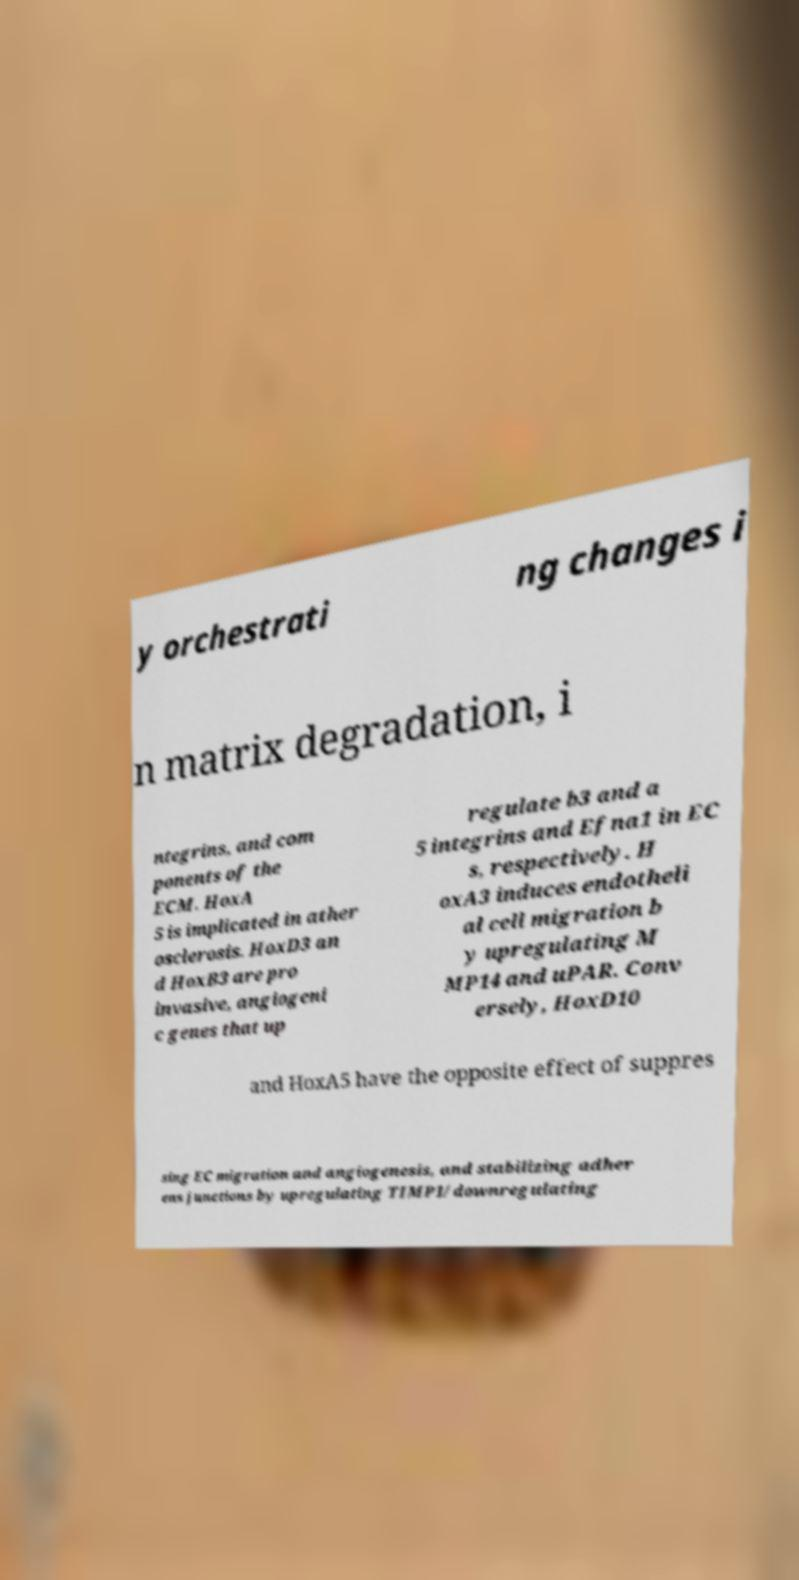What messages or text are displayed in this image? I need them in a readable, typed format. y orchestrati ng changes i n matrix degradation, i ntegrins, and com ponents of the ECM. HoxA 5 is implicated in ather osclerosis. HoxD3 an d HoxB3 are pro invasive, angiogeni c genes that up regulate b3 and a 5 integrins and Efna1 in EC s, respectively. H oxA3 induces endotheli al cell migration b y upregulating M MP14 and uPAR. Conv ersely, HoxD10 and HoxA5 have the opposite effect of suppres sing EC migration and angiogenesis, and stabilizing adher ens junctions by upregulating TIMP1/downregulating 